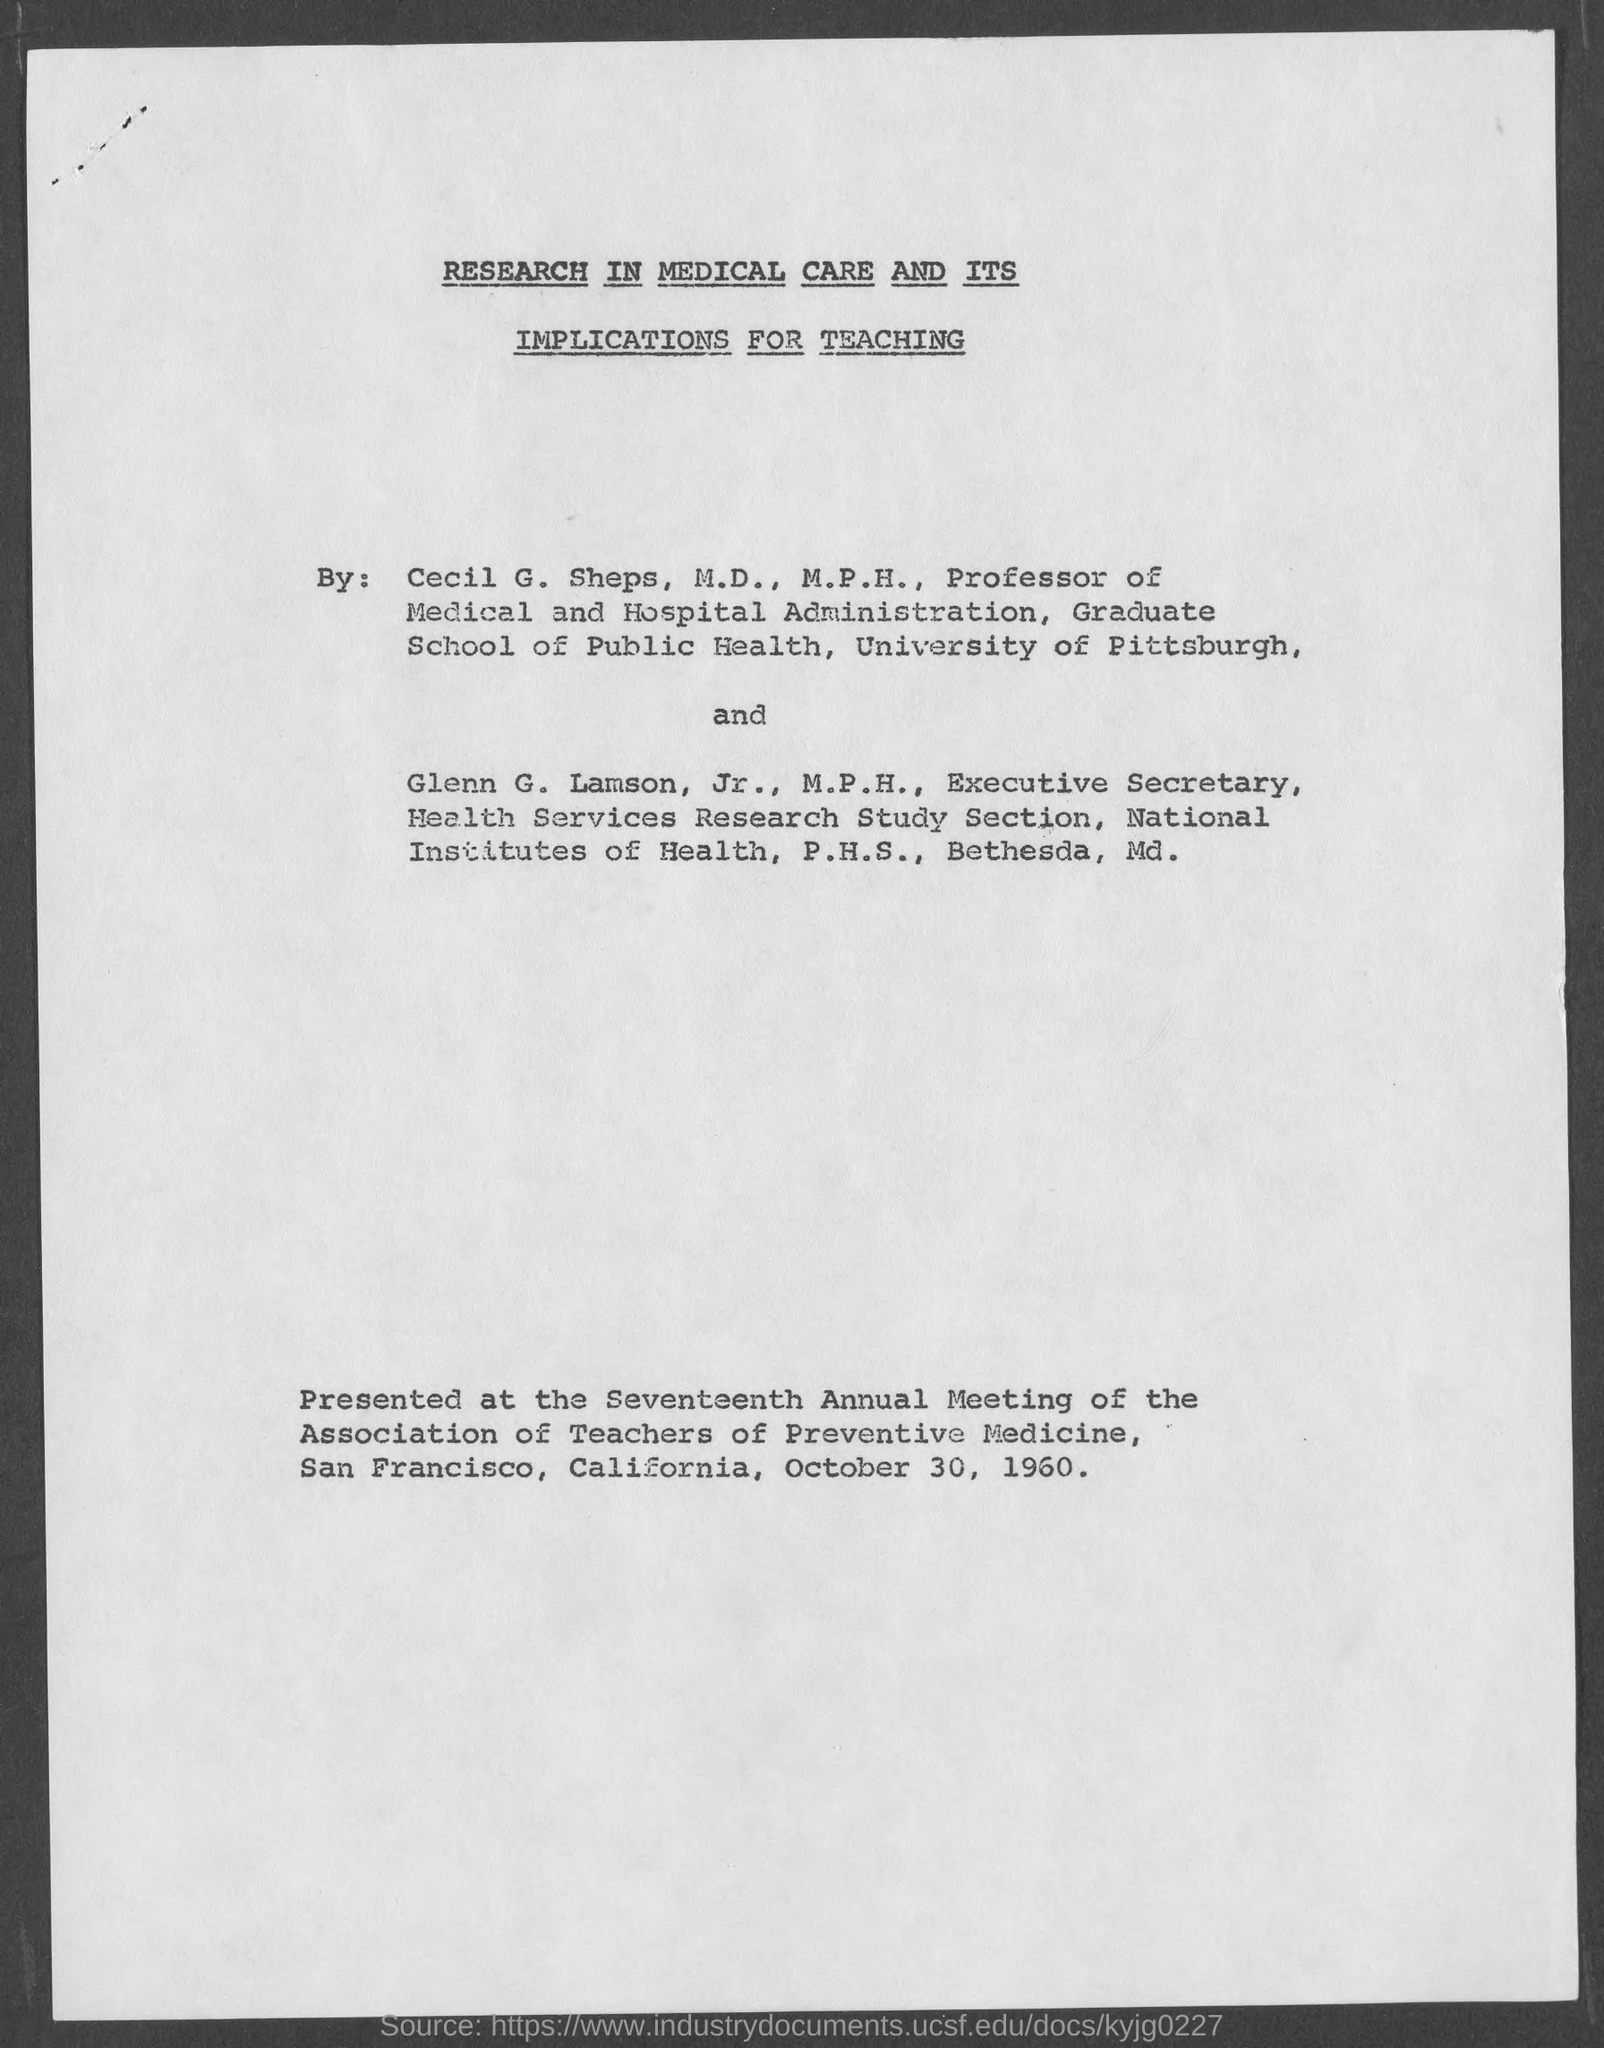Specify some key components in this picture. The Seventeenth Annual Meeting of the Association of Teachers of Preventive Medicine was held in San Francisco, California, on October 30, 1960. A paper on "Research in Medical Care and Its Implications for Teaching" was presented at the Seventeenth Annual Meeting of the Association of Teachers of Preventive Medicine. The Professor of Medical and Hospital Administration at the Graduate School of Public Health is Cecil G. Sheps. The Health Services Research Study Section is headed by Glenn G. Lamson, Jr., who holds a Master's degree in Public Health. 